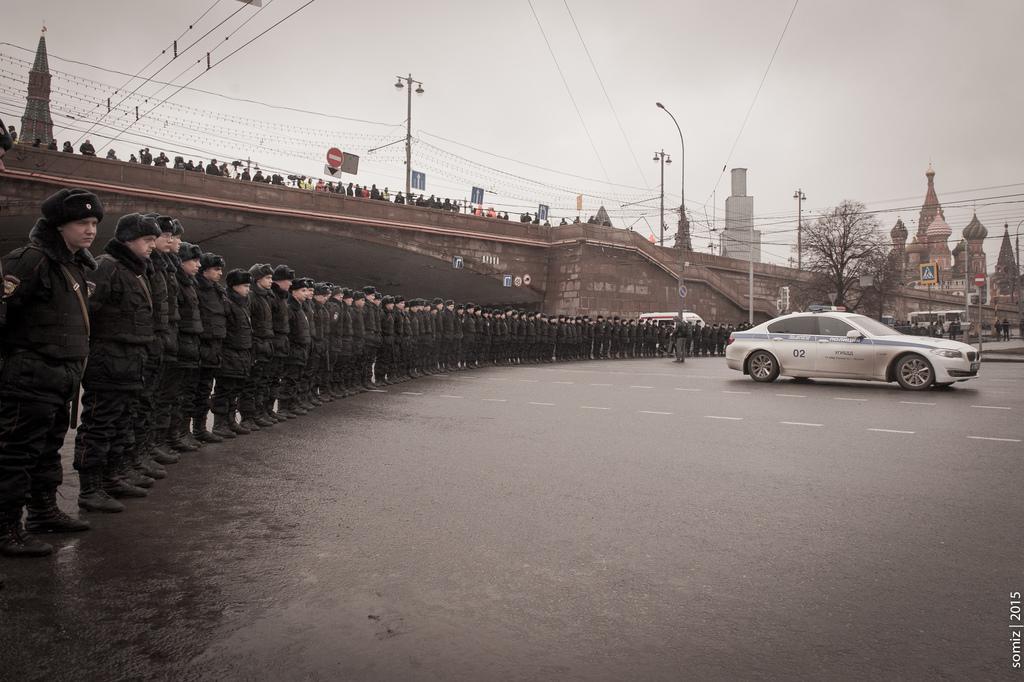Can you describe this image briefly? In this image we can see these people wearing black dresses, caps and shoes are standing in the line on the road. Here we can see vehicles moving on the road, we can see a bridge on which people are standing, we can see light poles, boards, wires, buildings, caution boards and the sky in the background. 